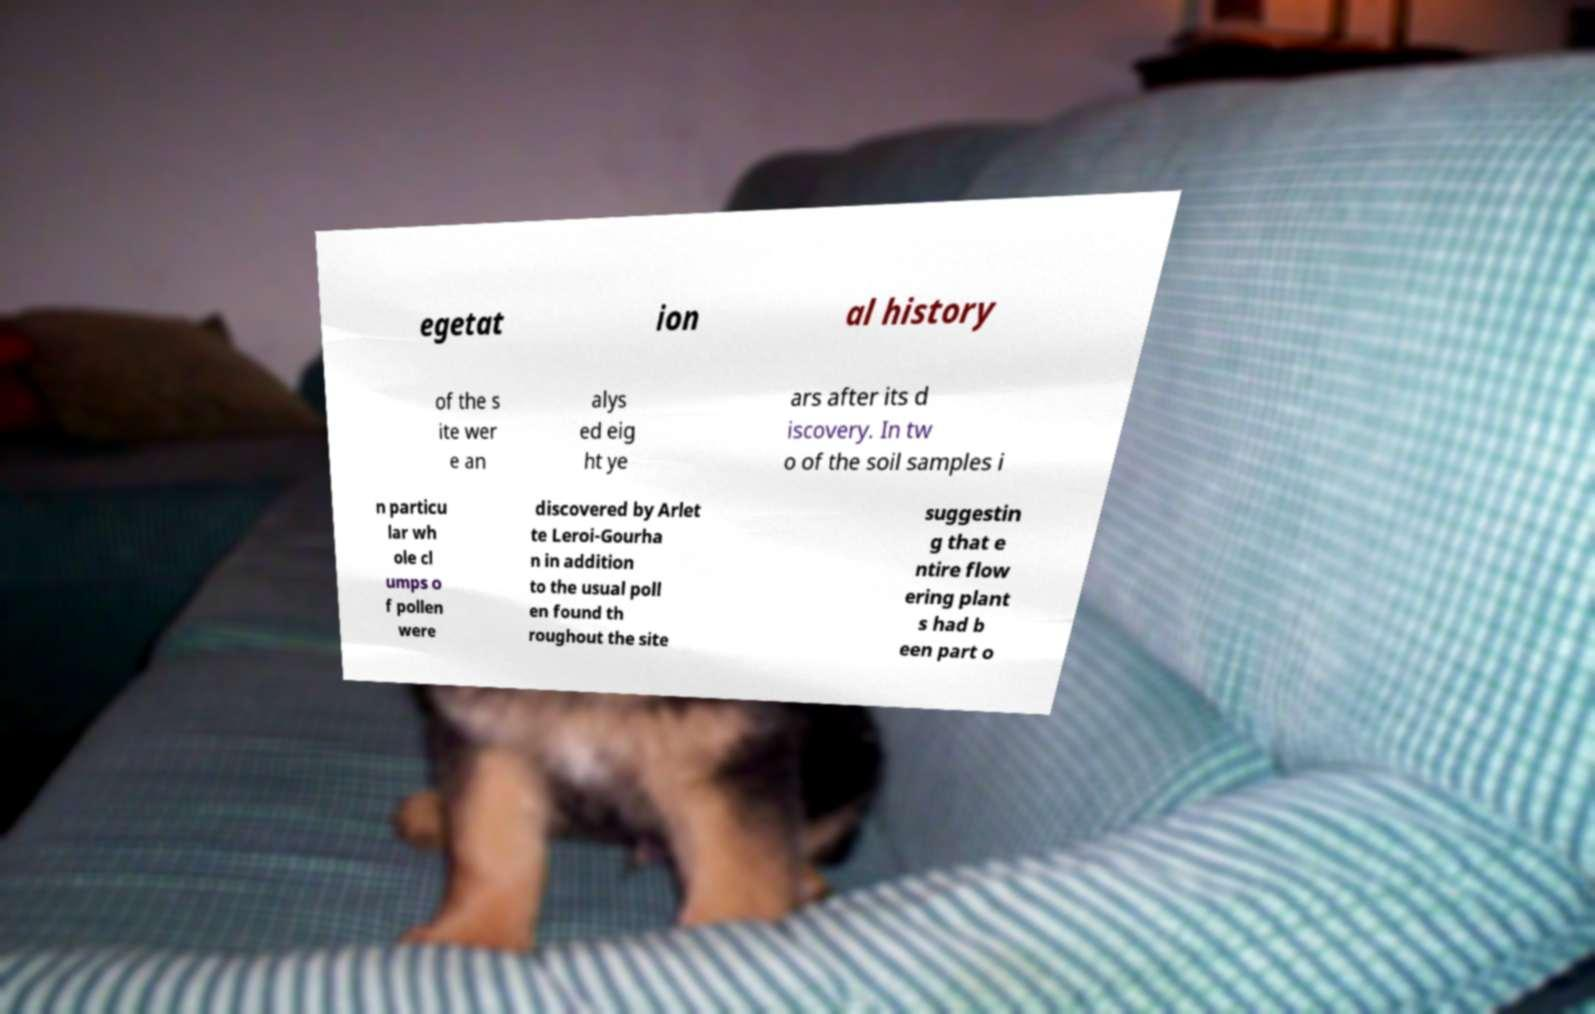Can you read and provide the text displayed in the image?This photo seems to have some interesting text. Can you extract and type it out for me? egetat ion al history of the s ite wer e an alys ed eig ht ye ars after its d iscovery. In tw o of the soil samples i n particu lar wh ole cl umps o f pollen were discovered by Arlet te Leroi-Gourha n in addition to the usual poll en found th roughout the site suggestin g that e ntire flow ering plant s had b een part o 